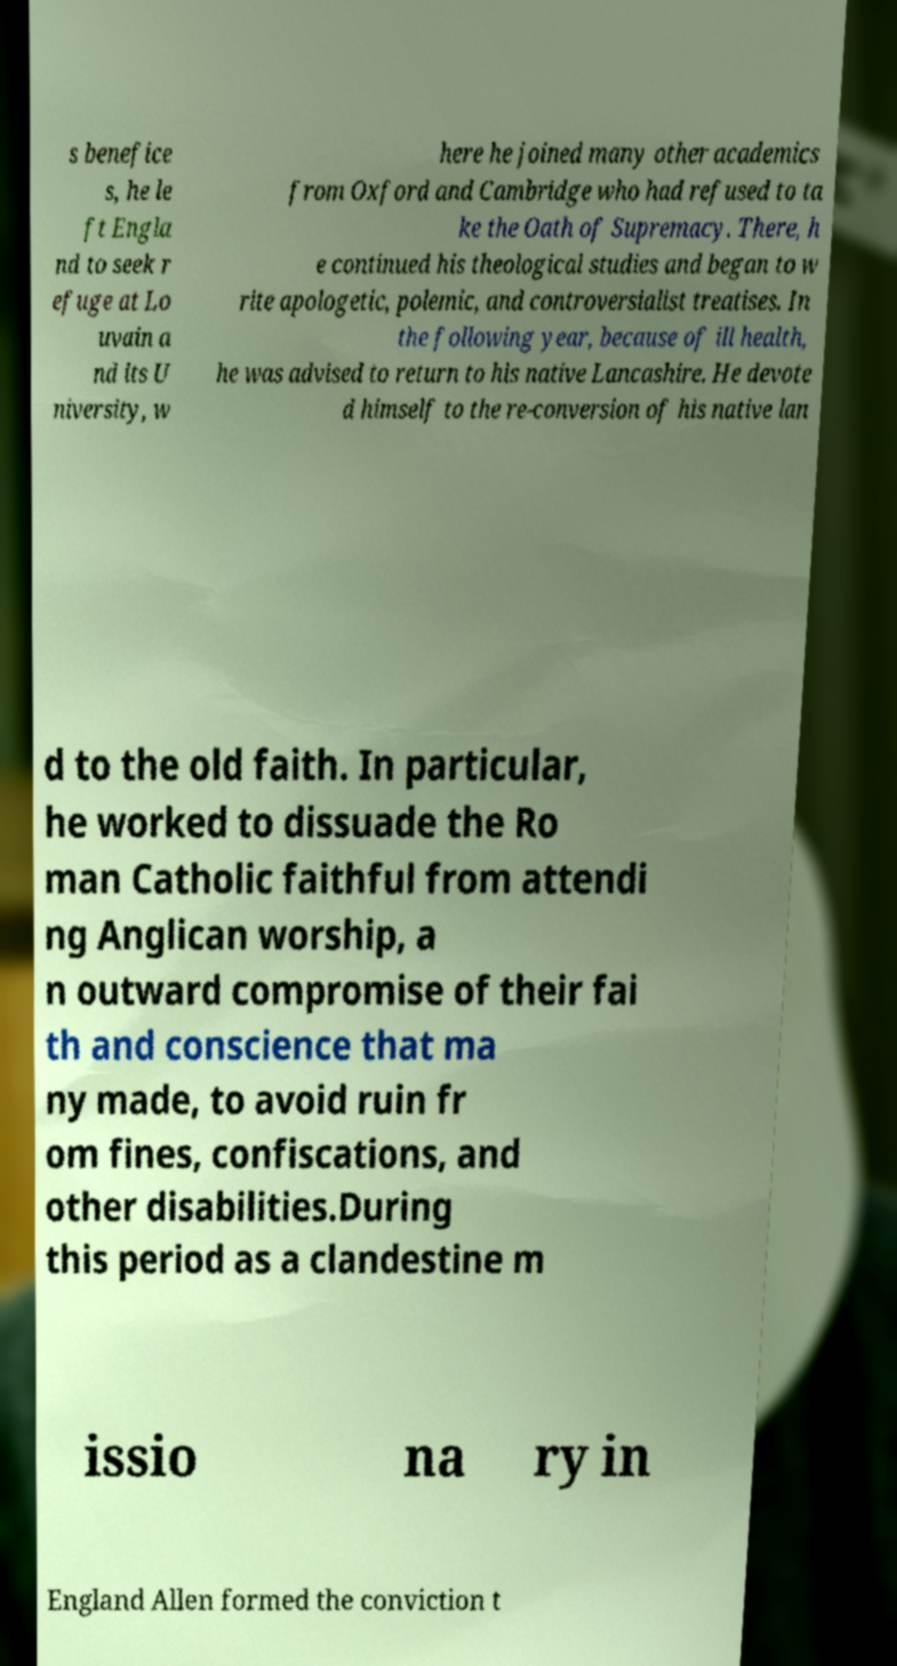What messages or text are displayed in this image? I need them in a readable, typed format. s benefice s, he le ft Engla nd to seek r efuge at Lo uvain a nd its U niversity, w here he joined many other academics from Oxford and Cambridge who had refused to ta ke the Oath of Supremacy. There, h e continued his theological studies and began to w rite apologetic, polemic, and controversialist treatises. In the following year, because of ill health, he was advised to return to his native Lancashire. He devote d himself to the re-conversion of his native lan d to the old faith. In particular, he worked to dissuade the Ro man Catholic faithful from attendi ng Anglican worship, a n outward compromise of their fai th and conscience that ma ny made, to avoid ruin fr om fines, confiscations, and other disabilities.During this period as a clandestine m issio na ry in England Allen formed the conviction t 